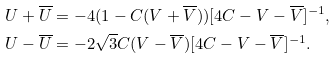Convert formula to latex. <formula><loc_0><loc_0><loc_500><loc_500>U + \overline { U } & = - 4 ( 1 - C ( V + \overline { V } ) ) [ 4 C - V - \overline { V } ] ^ { - 1 } , \\ U - \overline { U } & = - 2 \sqrt { 3 } C ( V - \overline { V } ) [ 4 C - V - \overline { V } ] ^ { - 1 } .</formula> 